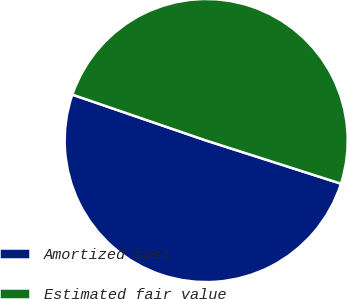Convert chart. <chart><loc_0><loc_0><loc_500><loc_500><pie_chart><fcel>Amortized cost<fcel>Estimated fair value<nl><fcel>50.33%<fcel>49.67%<nl></chart> 